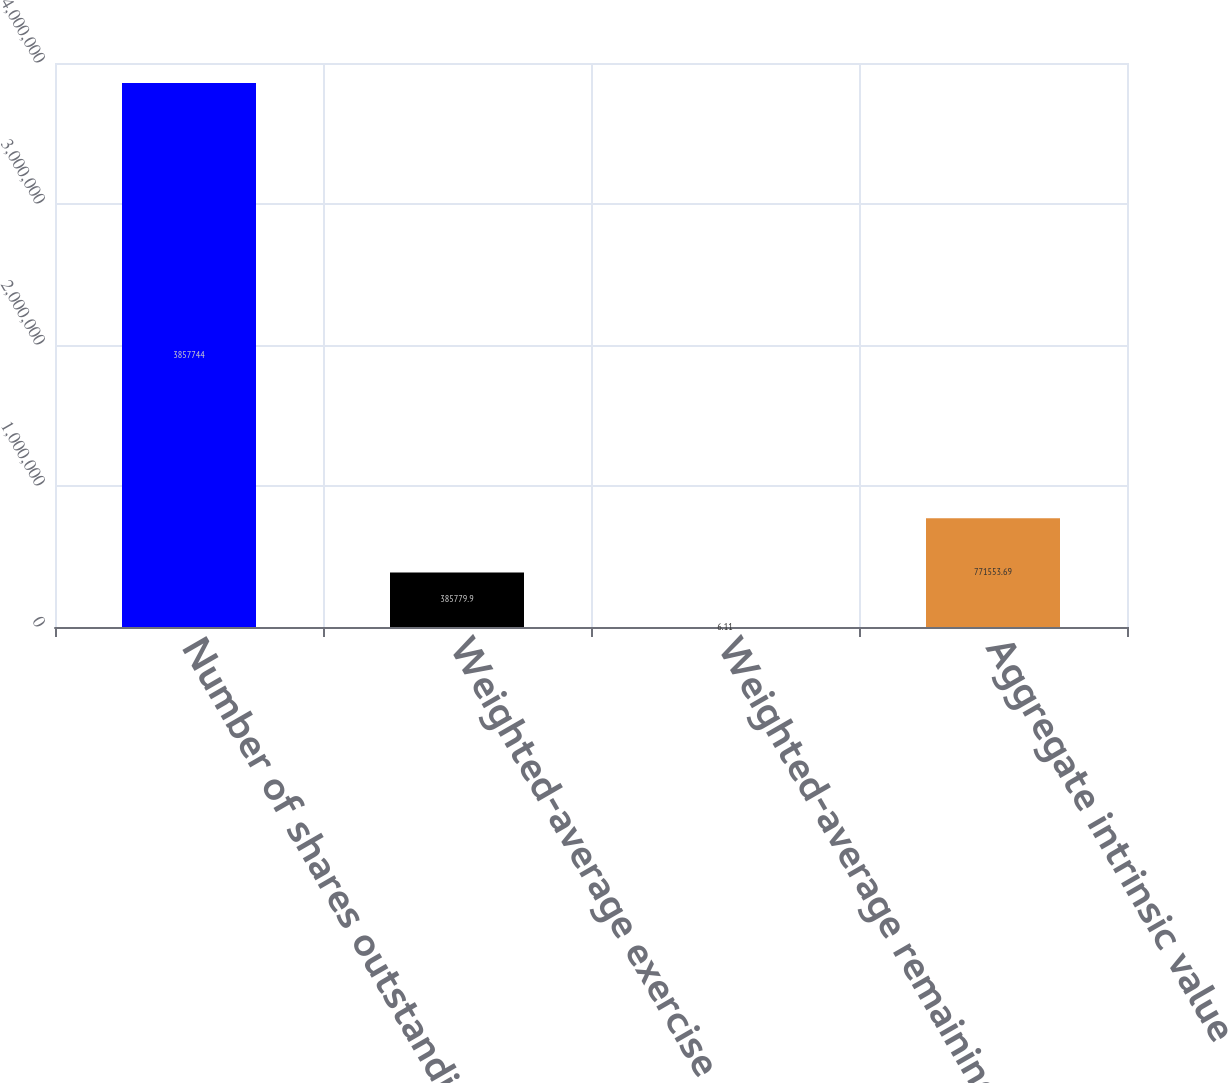Convert chart to OTSL. <chart><loc_0><loc_0><loc_500><loc_500><bar_chart><fcel>Number of shares outstanding<fcel>Weighted-average exercise<fcel>Weighted-average remaining<fcel>Aggregate intrinsic value<nl><fcel>3.85774e+06<fcel>385780<fcel>6.11<fcel>771554<nl></chart> 